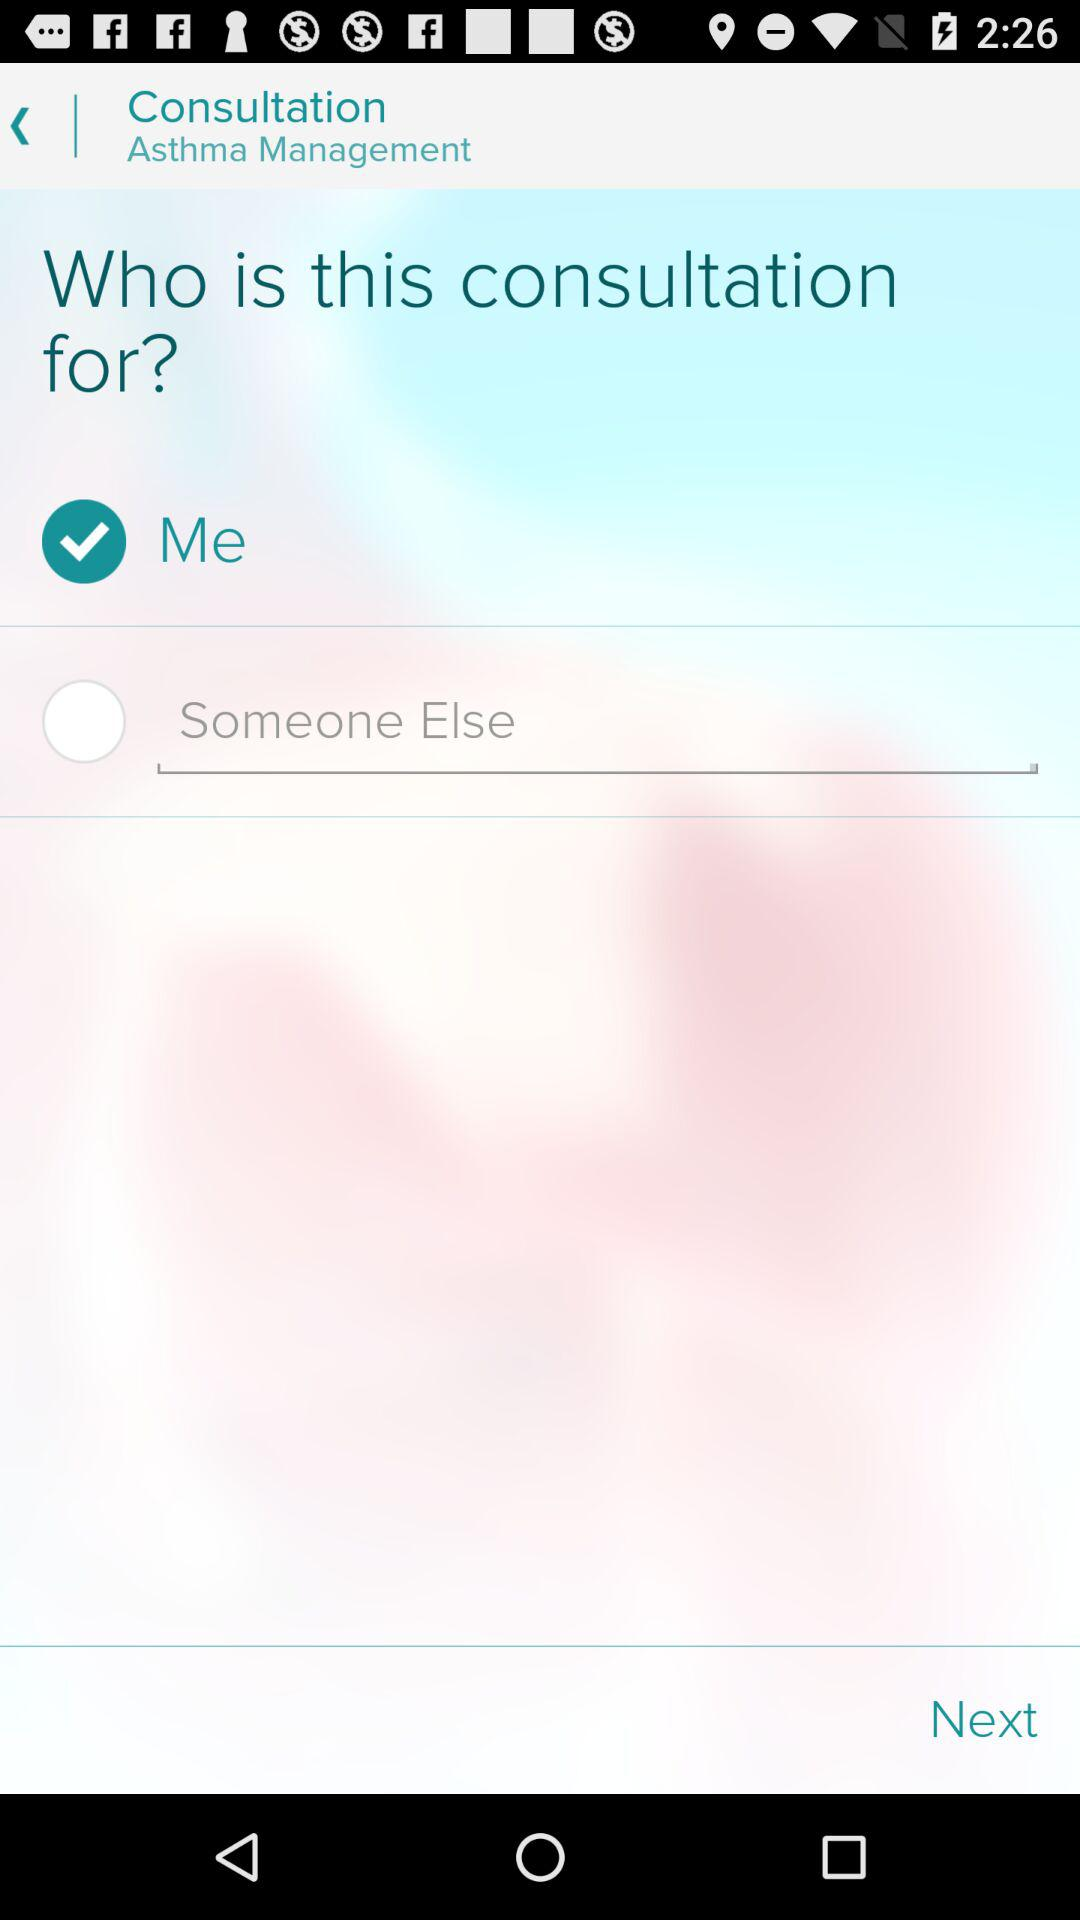Which option has been selected? The option that has been selected is "Me". 